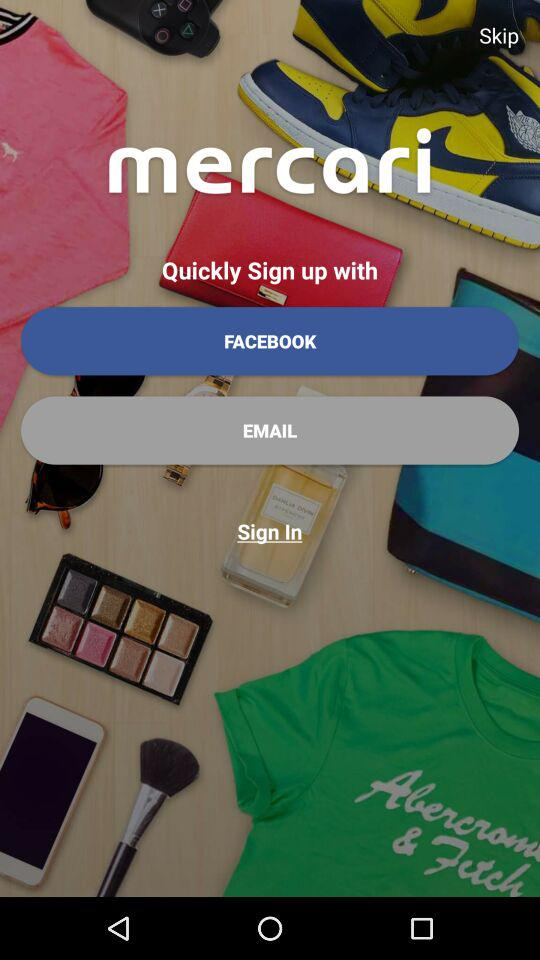What are the different options to "Sign up with"? The different options are "FACEBOOK" and "EMAIL". 